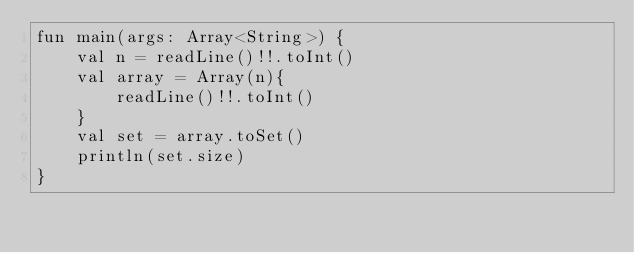Convert code to text. <code><loc_0><loc_0><loc_500><loc_500><_Kotlin_>fun main(args: Array<String>) {
    val n = readLine()!!.toInt()
    val array = Array(n){
        readLine()!!.toInt()
    }
    val set = array.toSet()
    println(set.size)
}</code> 